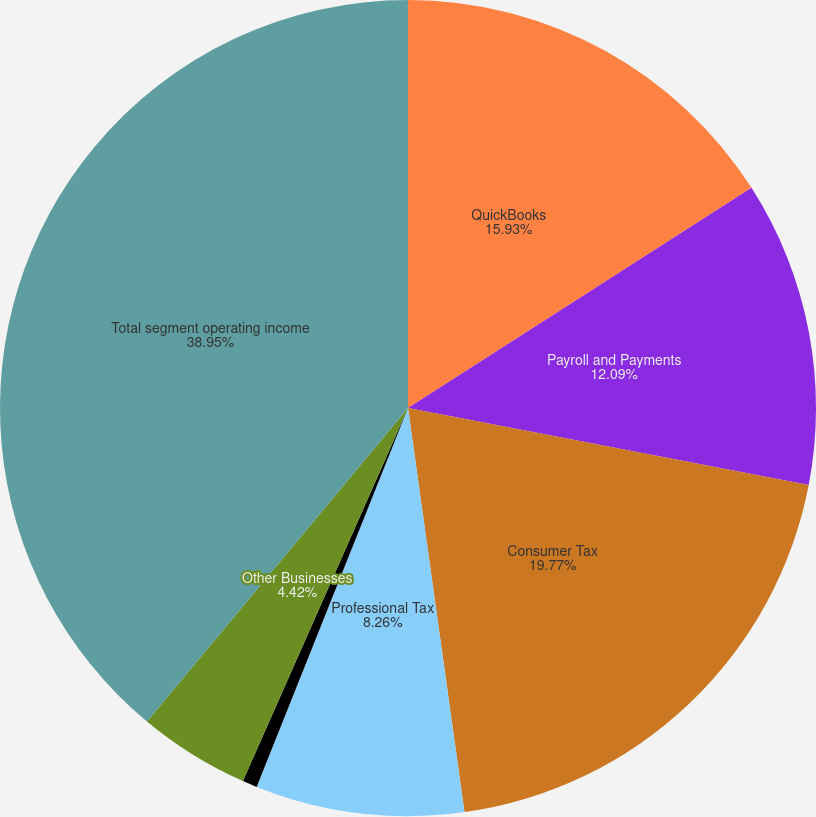Convert chart. <chart><loc_0><loc_0><loc_500><loc_500><pie_chart><fcel>QuickBooks<fcel>Payroll and Payments<fcel>Consumer Tax<fcel>Professional Tax<fcel>Financial Institutions<fcel>Other Businesses<fcel>Total segment operating income<nl><fcel>15.93%<fcel>12.09%<fcel>19.77%<fcel>8.26%<fcel>0.58%<fcel>4.42%<fcel>38.95%<nl></chart> 